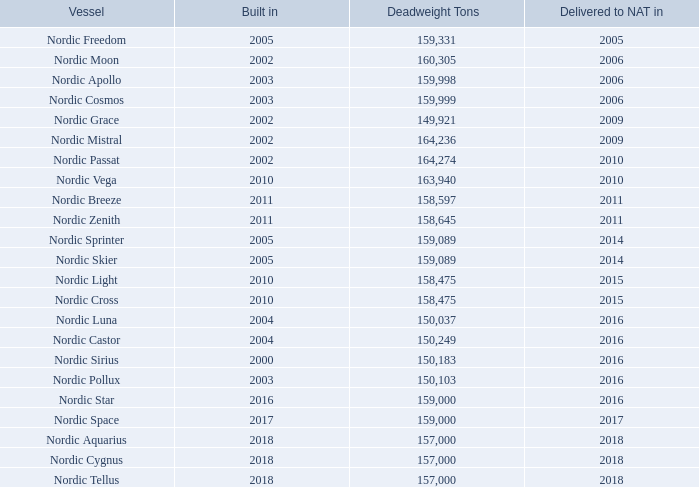B. Business Overview
Our Fleet
Our fleet currently consists of 23 Suezmax crude oil tankers, of which the vast majority have been built in Korea. The majority of our vessels are employed in the spot market, together with one vessel currently on a longer term time charter agreement expiring in 2021 or later. The vessels are considered homogenous and interchangeable as they have approximately the same freight capacity and ability to transport the same type of cargo.
What is the the respective years in which Nordic Freedom was built and delivered to NAT? 2005, 2005. What is the the respective years in which Nordic Moon was built and delivered to NAT? 2002, 2006. What is the the respective years in which Nordic Apollo was built and delivered to NAT? 2003, 2006. What is the total weight of Nordic Freedom and Nordic Moon? (159,331 + 160,305) 
Answer: 319636. What is the average weight of Nordic Freedom and Nordic Moon? (159,331 + 160,305)/2 
Answer: 159818. What is the weight of Nordic Moon as a percentage of the weight of Nordic Apollo?
Answer scale should be: percent. 160,305/159,998 
Answer: 100.19. 